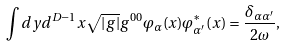<formula> <loc_0><loc_0><loc_500><loc_500>\int d y d ^ { D - 1 } x \sqrt { | g | } g ^ { 0 0 } \varphi _ { \alpha } ( x ) \varphi _ { \alpha ^ { \prime } } ^ { \ast } ( x ) = \frac { \delta _ { \alpha \alpha ^ { \prime } } } { 2 \omega } ,</formula> 